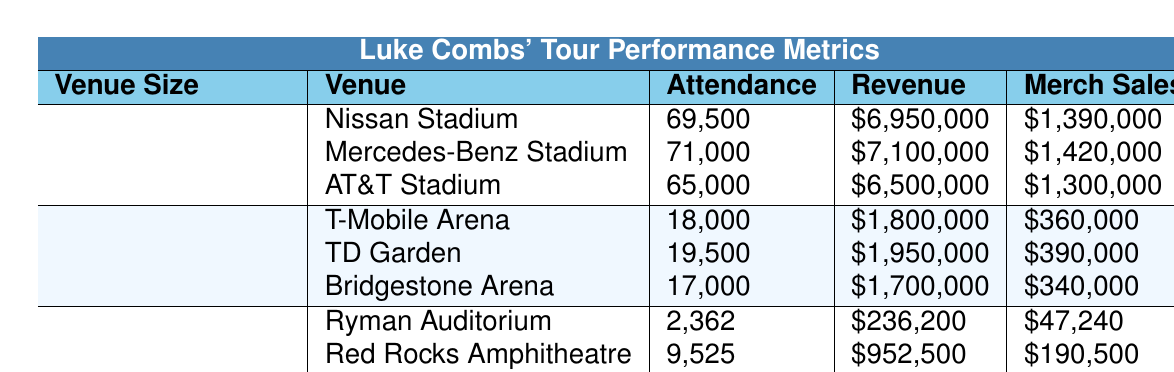What is the highest attendance recorded among the large venues? The attendance figures for large venues are Nissan Stadium (69,500), Mercedes-Benz Stadium (71,000), and AT&T Stadium (65,000). The highest attendance is from Mercedes-Benz Stadium, which had 71,000 attendees.
Answer: 71,000 What is the total revenue generated from all small venues? The revenue from small venues is $236,200 (Ryman Auditorium) + $952,500 (Red Rocks Amphitheatre) + $600,000 (The Anthem) = $1,788,700.
Answer: $1,788,700 Which medium venue had the lowest merchandise sales? The merchandise sales for medium venues are $360,000 (T-Mobile Arena), $390,000 (TD Garden), and $340,000 (Bridgestone Arena). Bridgestone Arena had the lowest sales of $340,000.
Answer: $340,000 What is the average ticket price range at large venues? The ticket price ranges for large venues are between $49.50 - $250 (Nissan Stadium), $55 - $275 (Mercedes-Benz Stadium), and $45 - $225 (AT&T Stadium). To find the average, calculate the average of the ranges: (49.50 + 250)/2 = 134.75, (55 + 275)/2 = 165, (45 + 225)/2 = 135. The averages are approximately $134.75, $165, and $135. The overall average is (134.75 + 165 + 135)/3 = 144.58.
Answer: $144.58 Did any venue generate over $2 million in revenue? Reviewing the revenue figures, all large venues and the medium venue TD Garden ($1,950,000) exceed $2 million. Therefore, the answer is yes.
Answer: Yes What is the difference in average attendance between large and small venues? The average attendance for large venues is (69,500 + 71,000 + 65,000)/3 = 68,500, while for small venues it is (2,362 + 9,525 + 6,000)/3 = 5,962. The difference is 68,500 - 5,962 = 62,538.
Answer: 62,538 Which venue had the highest merchandise sales? Analyzing merchandise sales: $1,390,000 (Nissan Stadium), $1,420,000 (Mercedes-Benz Stadium), $1,300,000 (AT&T Stadium) for large venues; $360,000 (T-Mobile Arena), $390,000 (TD Garden), $340,000 (Bridgestone Arena) for medium venues; $47,240 (Ryman Auditorium), $190,500 (Red Rocks Amphitheatre), $120,000 (The Anthem) for small venues. The highest sales were from Mercedes-Benz Stadium at $1,420,000.
Answer: $1,420,000 What is the total attendance for all medium venues? The total attendance for medium venues is calculated as 18,000 (T-Mobile Arena) + 19,500 (TD Garden) + 17,000 (Bridgestone Arena) = 54,500.
Answer: 54,500 Is the average revenue of small venues greater than $1 million? Total revenue for small venues is $236,200 + $952,500 + $600,000 = $1,788,700. The average revenue is $1,788,700 / 3 = $596,233.33, which is less than $1 million. Therefore, the answer is no.
Answer: No What is the median ticket price range for all venues combined? To find the median ticket price range, we consider the ranges: large venues (average: $134.75), medium venues (average: $61.67), and small venues (average: $75). Arranging these values: $61.67, $75, $134.75, we find the median (middle value) is approximately $75.
Answer: $75 